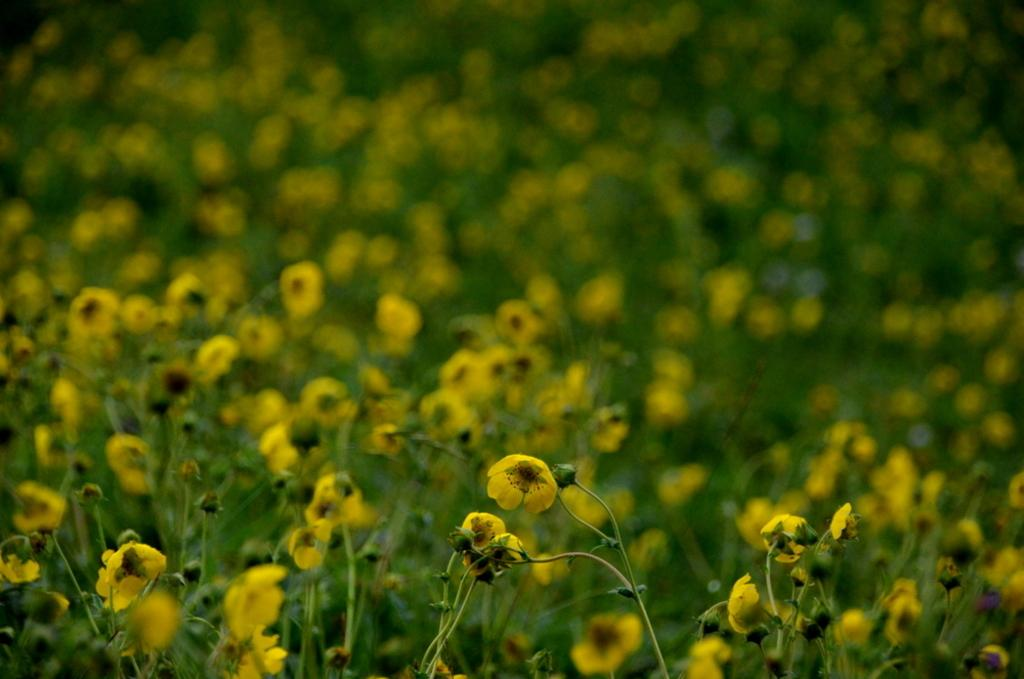What type of plants can be seen in the image? There are small plants in the image. What color are the flowers on the plants? The flowers on the plants are yellow. What color are the stems of the plants? The stems of the plants are green. Where is the coast visible in the image? There is no coast visible in the image; it features small plants with yellow flowers and green stems. 